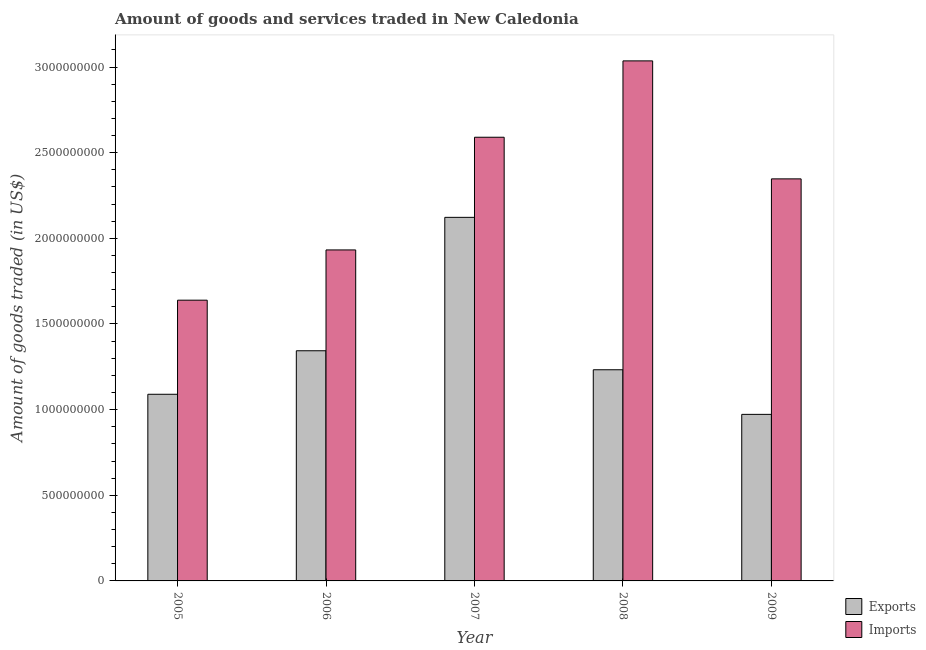How many different coloured bars are there?
Give a very brief answer. 2. How many groups of bars are there?
Offer a terse response. 5. Are the number of bars per tick equal to the number of legend labels?
Make the answer very short. Yes. What is the label of the 3rd group of bars from the left?
Your answer should be compact. 2007. In how many cases, is the number of bars for a given year not equal to the number of legend labels?
Give a very brief answer. 0. What is the amount of goods imported in 2008?
Provide a short and direct response. 3.04e+09. Across all years, what is the maximum amount of goods exported?
Your response must be concise. 2.12e+09. Across all years, what is the minimum amount of goods imported?
Your response must be concise. 1.64e+09. In which year was the amount of goods imported maximum?
Ensure brevity in your answer.  2008. In which year was the amount of goods imported minimum?
Give a very brief answer. 2005. What is the total amount of goods exported in the graph?
Offer a terse response. 6.76e+09. What is the difference between the amount of goods exported in 2005 and that in 2009?
Ensure brevity in your answer.  1.17e+08. What is the difference between the amount of goods imported in 2008 and the amount of goods exported in 2009?
Keep it short and to the point. 6.89e+08. What is the average amount of goods exported per year?
Offer a terse response. 1.35e+09. What is the ratio of the amount of goods exported in 2006 to that in 2009?
Provide a succinct answer. 1.38. What is the difference between the highest and the second highest amount of goods imported?
Provide a short and direct response. 4.46e+08. What is the difference between the highest and the lowest amount of goods exported?
Make the answer very short. 1.15e+09. In how many years, is the amount of goods exported greater than the average amount of goods exported taken over all years?
Give a very brief answer. 1. What does the 1st bar from the left in 2007 represents?
Offer a very short reply. Exports. What does the 1st bar from the right in 2005 represents?
Your answer should be very brief. Imports. How many bars are there?
Provide a short and direct response. 10. Are all the bars in the graph horizontal?
Provide a short and direct response. No. What is the difference between two consecutive major ticks on the Y-axis?
Give a very brief answer. 5.00e+08. Are the values on the major ticks of Y-axis written in scientific E-notation?
Your answer should be very brief. No. Where does the legend appear in the graph?
Ensure brevity in your answer.  Bottom right. How are the legend labels stacked?
Provide a short and direct response. Vertical. What is the title of the graph?
Keep it short and to the point. Amount of goods and services traded in New Caledonia. Does "Official aid received" appear as one of the legend labels in the graph?
Make the answer very short. No. What is the label or title of the Y-axis?
Your answer should be compact. Amount of goods traded (in US$). What is the Amount of goods traded (in US$) of Exports in 2005?
Ensure brevity in your answer.  1.09e+09. What is the Amount of goods traded (in US$) in Imports in 2005?
Offer a very short reply. 1.64e+09. What is the Amount of goods traded (in US$) in Exports in 2006?
Give a very brief answer. 1.34e+09. What is the Amount of goods traded (in US$) of Imports in 2006?
Provide a short and direct response. 1.93e+09. What is the Amount of goods traded (in US$) of Exports in 2007?
Make the answer very short. 2.12e+09. What is the Amount of goods traded (in US$) in Imports in 2007?
Your answer should be compact. 2.59e+09. What is the Amount of goods traded (in US$) in Exports in 2008?
Provide a succinct answer. 1.23e+09. What is the Amount of goods traded (in US$) in Imports in 2008?
Provide a succinct answer. 3.04e+09. What is the Amount of goods traded (in US$) in Exports in 2009?
Ensure brevity in your answer.  9.72e+08. What is the Amount of goods traded (in US$) in Imports in 2009?
Offer a terse response. 2.35e+09. Across all years, what is the maximum Amount of goods traded (in US$) in Exports?
Make the answer very short. 2.12e+09. Across all years, what is the maximum Amount of goods traded (in US$) of Imports?
Provide a short and direct response. 3.04e+09. Across all years, what is the minimum Amount of goods traded (in US$) of Exports?
Ensure brevity in your answer.  9.72e+08. Across all years, what is the minimum Amount of goods traded (in US$) of Imports?
Keep it short and to the point. 1.64e+09. What is the total Amount of goods traded (in US$) of Exports in the graph?
Keep it short and to the point. 6.76e+09. What is the total Amount of goods traded (in US$) of Imports in the graph?
Offer a very short reply. 1.15e+1. What is the difference between the Amount of goods traded (in US$) of Exports in 2005 and that in 2006?
Your response must be concise. -2.54e+08. What is the difference between the Amount of goods traded (in US$) of Imports in 2005 and that in 2006?
Make the answer very short. -2.93e+08. What is the difference between the Amount of goods traded (in US$) in Exports in 2005 and that in 2007?
Provide a succinct answer. -1.03e+09. What is the difference between the Amount of goods traded (in US$) of Imports in 2005 and that in 2007?
Offer a very short reply. -9.51e+08. What is the difference between the Amount of goods traded (in US$) of Exports in 2005 and that in 2008?
Make the answer very short. -1.43e+08. What is the difference between the Amount of goods traded (in US$) in Imports in 2005 and that in 2008?
Offer a very short reply. -1.40e+09. What is the difference between the Amount of goods traded (in US$) of Exports in 2005 and that in 2009?
Provide a succinct answer. 1.17e+08. What is the difference between the Amount of goods traded (in US$) in Imports in 2005 and that in 2009?
Your response must be concise. -7.08e+08. What is the difference between the Amount of goods traded (in US$) in Exports in 2006 and that in 2007?
Make the answer very short. -7.79e+08. What is the difference between the Amount of goods traded (in US$) in Imports in 2006 and that in 2007?
Your answer should be compact. -6.58e+08. What is the difference between the Amount of goods traded (in US$) of Exports in 2006 and that in 2008?
Provide a succinct answer. 1.11e+08. What is the difference between the Amount of goods traded (in US$) of Imports in 2006 and that in 2008?
Make the answer very short. -1.10e+09. What is the difference between the Amount of goods traded (in US$) of Exports in 2006 and that in 2009?
Provide a succinct answer. 3.71e+08. What is the difference between the Amount of goods traded (in US$) in Imports in 2006 and that in 2009?
Make the answer very short. -4.15e+08. What is the difference between the Amount of goods traded (in US$) of Exports in 2007 and that in 2008?
Provide a short and direct response. 8.90e+08. What is the difference between the Amount of goods traded (in US$) of Imports in 2007 and that in 2008?
Your response must be concise. -4.46e+08. What is the difference between the Amount of goods traded (in US$) of Exports in 2007 and that in 2009?
Offer a very short reply. 1.15e+09. What is the difference between the Amount of goods traded (in US$) in Imports in 2007 and that in 2009?
Make the answer very short. 2.43e+08. What is the difference between the Amount of goods traded (in US$) in Exports in 2008 and that in 2009?
Give a very brief answer. 2.60e+08. What is the difference between the Amount of goods traded (in US$) in Imports in 2008 and that in 2009?
Give a very brief answer. 6.89e+08. What is the difference between the Amount of goods traded (in US$) of Exports in 2005 and the Amount of goods traded (in US$) of Imports in 2006?
Provide a short and direct response. -8.43e+08. What is the difference between the Amount of goods traded (in US$) in Exports in 2005 and the Amount of goods traded (in US$) in Imports in 2007?
Provide a succinct answer. -1.50e+09. What is the difference between the Amount of goods traded (in US$) of Exports in 2005 and the Amount of goods traded (in US$) of Imports in 2008?
Offer a terse response. -1.95e+09. What is the difference between the Amount of goods traded (in US$) of Exports in 2005 and the Amount of goods traded (in US$) of Imports in 2009?
Offer a terse response. -1.26e+09. What is the difference between the Amount of goods traded (in US$) in Exports in 2006 and the Amount of goods traded (in US$) in Imports in 2007?
Offer a terse response. -1.25e+09. What is the difference between the Amount of goods traded (in US$) of Exports in 2006 and the Amount of goods traded (in US$) of Imports in 2008?
Your answer should be compact. -1.69e+09. What is the difference between the Amount of goods traded (in US$) of Exports in 2006 and the Amount of goods traded (in US$) of Imports in 2009?
Keep it short and to the point. -1.00e+09. What is the difference between the Amount of goods traded (in US$) of Exports in 2007 and the Amount of goods traded (in US$) of Imports in 2008?
Provide a short and direct response. -9.13e+08. What is the difference between the Amount of goods traded (in US$) of Exports in 2007 and the Amount of goods traded (in US$) of Imports in 2009?
Provide a succinct answer. -2.25e+08. What is the difference between the Amount of goods traded (in US$) of Exports in 2008 and the Amount of goods traded (in US$) of Imports in 2009?
Your response must be concise. -1.11e+09. What is the average Amount of goods traded (in US$) of Exports per year?
Offer a terse response. 1.35e+09. What is the average Amount of goods traded (in US$) of Imports per year?
Offer a terse response. 2.31e+09. In the year 2005, what is the difference between the Amount of goods traded (in US$) of Exports and Amount of goods traded (in US$) of Imports?
Your response must be concise. -5.49e+08. In the year 2006, what is the difference between the Amount of goods traded (in US$) in Exports and Amount of goods traded (in US$) in Imports?
Offer a terse response. -5.89e+08. In the year 2007, what is the difference between the Amount of goods traded (in US$) of Exports and Amount of goods traded (in US$) of Imports?
Provide a succinct answer. -4.68e+08. In the year 2008, what is the difference between the Amount of goods traded (in US$) of Exports and Amount of goods traded (in US$) of Imports?
Provide a short and direct response. -1.80e+09. In the year 2009, what is the difference between the Amount of goods traded (in US$) in Exports and Amount of goods traded (in US$) in Imports?
Give a very brief answer. -1.37e+09. What is the ratio of the Amount of goods traded (in US$) in Exports in 2005 to that in 2006?
Make the answer very short. 0.81. What is the ratio of the Amount of goods traded (in US$) in Imports in 2005 to that in 2006?
Your answer should be compact. 0.85. What is the ratio of the Amount of goods traded (in US$) in Exports in 2005 to that in 2007?
Your answer should be very brief. 0.51. What is the ratio of the Amount of goods traded (in US$) in Imports in 2005 to that in 2007?
Offer a very short reply. 0.63. What is the ratio of the Amount of goods traded (in US$) in Exports in 2005 to that in 2008?
Offer a terse response. 0.88. What is the ratio of the Amount of goods traded (in US$) in Imports in 2005 to that in 2008?
Offer a terse response. 0.54. What is the ratio of the Amount of goods traded (in US$) in Exports in 2005 to that in 2009?
Provide a short and direct response. 1.12. What is the ratio of the Amount of goods traded (in US$) of Imports in 2005 to that in 2009?
Your answer should be compact. 0.7. What is the ratio of the Amount of goods traded (in US$) in Exports in 2006 to that in 2007?
Provide a succinct answer. 0.63. What is the ratio of the Amount of goods traded (in US$) in Imports in 2006 to that in 2007?
Provide a short and direct response. 0.75. What is the ratio of the Amount of goods traded (in US$) of Exports in 2006 to that in 2008?
Provide a short and direct response. 1.09. What is the ratio of the Amount of goods traded (in US$) in Imports in 2006 to that in 2008?
Your response must be concise. 0.64. What is the ratio of the Amount of goods traded (in US$) of Exports in 2006 to that in 2009?
Make the answer very short. 1.38. What is the ratio of the Amount of goods traded (in US$) in Imports in 2006 to that in 2009?
Keep it short and to the point. 0.82. What is the ratio of the Amount of goods traded (in US$) of Exports in 2007 to that in 2008?
Give a very brief answer. 1.72. What is the ratio of the Amount of goods traded (in US$) in Imports in 2007 to that in 2008?
Your response must be concise. 0.85. What is the ratio of the Amount of goods traded (in US$) in Exports in 2007 to that in 2009?
Provide a short and direct response. 2.18. What is the ratio of the Amount of goods traded (in US$) of Imports in 2007 to that in 2009?
Offer a very short reply. 1.1. What is the ratio of the Amount of goods traded (in US$) in Exports in 2008 to that in 2009?
Keep it short and to the point. 1.27. What is the ratio of the Amount of goods traded (in US$) of Imports in 2008 to that in 2009?
Your response must be concise. 1.29. What is the difference between the highest and the second highest Amount of goods traded (in US$) of Exports?
Make the answer very short. 7.79e+08. What is the difference between the highest and the second highest Amount of goods traded (in US$) in Imports?
Provide a succinct answer. 4.46e+08. What is the difference between the highest and the lowest Amount of goods traded (in US$) in Exports?
Ensure brevity in your answer.  1.15e+09. What is the difference between the highest and the lowest Amount of goods traded (in US$) of Imports?
Provide a succinct answer. 1.40e+09. 